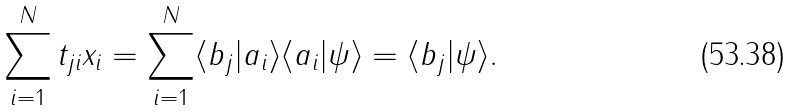<formula> <loc_0><loc_0><loc_500><loc_500>\sum _ { i = 1 } ^ { N } t _ { j i } x _ { i } = \sum _ { i = 1 } ^ { N } \langle b _ { j } | a _ { i } \rangle \langle a _ { i } | \psi \rangle = \langle b _ { j } | \psi \rangle .</formula> 